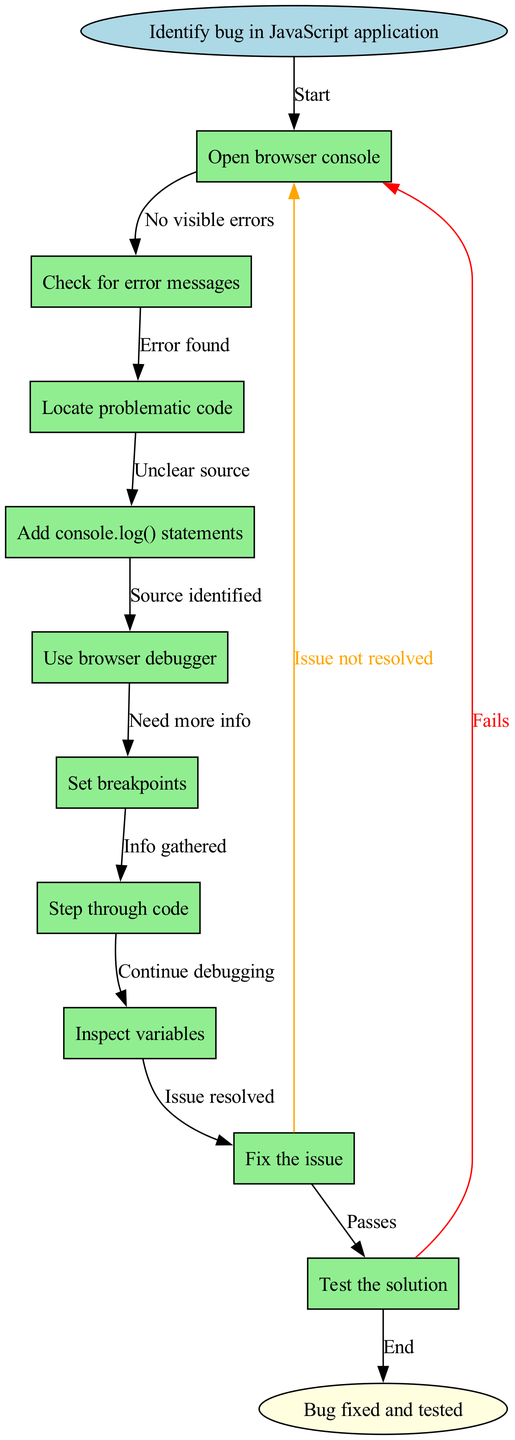What is the starting point of the debugging process? The starting point is labeled as "Identify bug in JavaScript application" in the diagram. This is indicated as the first node in the flow.
Answer: Identify bug in JavaScript application How many process nodes are there in the diagram? There are 10 process nodes listed, each representing a step in the debugging process. Counting these nodes confirms the total.
Answer: 10 Which node comes after checking for error messages? The node "Locate problematic code" comes directly after "Check for error messages" according to the flow of the diagram. This is shown by the edge connecting these two nodes.
Answer: Locate problematic code What action should be taken if there are no visible errors? If there are no visible errors, the process indicates to "Continue debugging", which flows from the relevant process node.
Answer: Continue debugging What is the final result indicated in the flow? The final result shown in the diagram is "Bug fixed and tested," located at the end of the flow. This is indicated as the last node in the diagram.
Answer: Bug fixed and tested If the issue is not resolved after testing, where do you go next? After testing, if the issue is not resolved, the flow leads back to the node for "Identify bug in JavaScript application". This loop is indicated by the edge labeled "Fails".
Answer: Identify bug in JavaScript application Which node indicates the gathering of information? The node labeled "Info gathered" indicates the stage of gathering additional information during the debugging process, connecting from "Need more info."
Answer: Info gathered What should be done if the issue is resolved? If the issue is resolved, the next step according to the flow is to "Test the solution", connecting from the resolution node.
Answer: Test the solution What color are the process nodes in the diagram? The process nodes are filled with light green color, as specified in the attributes for the nodes in the diagram.
Answer: Light green 